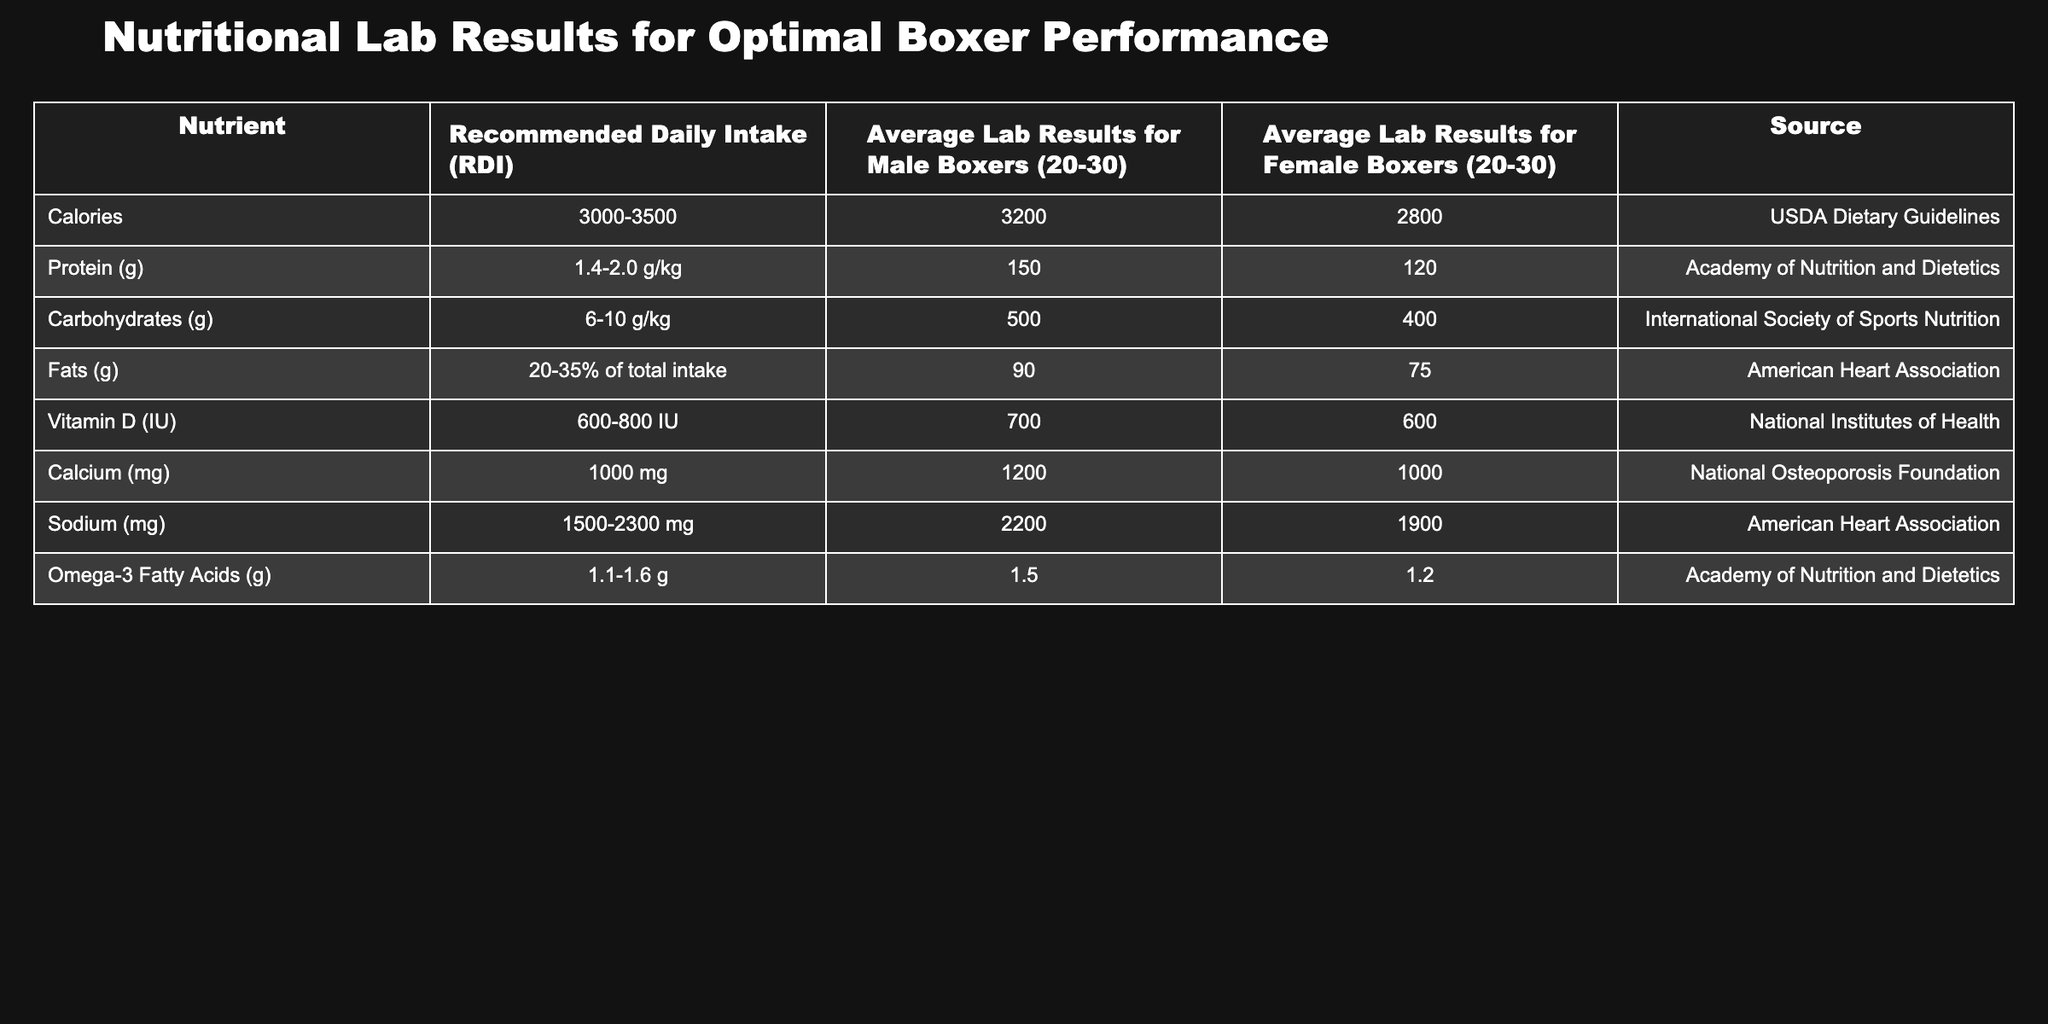What is the average protein intake for male boxers? The table shows the average lab results for protein intake for male boxers as 150 g.
Answer: 150 g What is the recommended daily intake of calories for female boxers? According to the table, the recommended daily intake of calories for female boxers is between 3000 and 3500.
Answer: 3000-3500 Is the average sodium intake for female boxers above the recommended daily intake? The recommended daily intake for sodium is 1500-2300 mg. The average lab result for female boxers is 1900 mg, which falls within this range, indicating it is not above.
Answer: No What is the difference in average fat intake between male and female boxers? The average fat intake for male boxers is 90 g and for female boxers is 75 g. The difference is 90 g - 75 g = 15 g.
Answer: 15 g Do male boxers have a higher average calcium intake compared to the recommended daily intake? The recommended daily intake for calcium is 1000 mg, while the average intake for male boxers is 1200 mg, indicating that male boxers exceed the recommendation.
Answer: Yes What is the average intake of carbohydrates for male and female boxers combined? The average intake for male boxers is 500 g and for female boxers is 400 g. The total is 500 g + 400 g = 900 g. Therefore, the average combined intake is 900 g / 2 = 450 g.
Answer: 450 g Which nutrient has the highest difference between average male and female boxer intakes? The highest difference is in protein intake, where male boxers have 150 g and female boxers 120 g. The difference is 150 g - 120 g = 30 g, which is more than the differences in other nutrients.
Answer: Protein Is the average vitamin D intake above the recommended level for female boxers? The recommended intake for vitamin D is 600-800 IU. The average intake for female boxers is 600 IU, which is at the minimum of the range, meaning it is not above.
Answer: No 